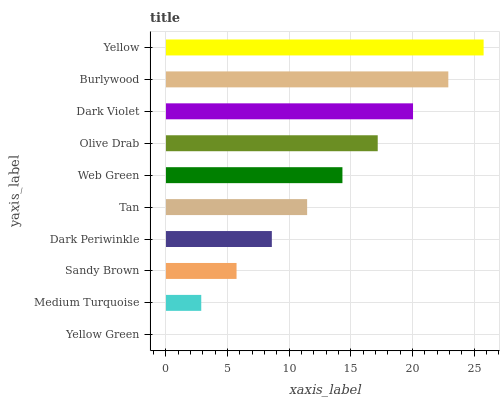Is Yellow Green the minimum?
Answer yes or no. Yes. Is Yellow the maximum?
Answer yes or no. Yes. Is Medium Turquoise the minimum?
Answer yes or no. No. Is Medium Turquoise the maximum?
Answer yes or no. No. Is Medium Turquoise greater than Yellow Green?
Answer yes or no. Yes. Is Yellow Green less than Medium Turquoise?
Answer yes or no. Yes. Is Yellow Green greater than Medium Turquoise?
Answer yes or no. No. Is Medium Turquoise less than Yellow Green?
Answer yes or no. No. Is Web Green the high median?
Answer yes or no. Yes. Is Tan the low median?
Answer yes or no. Yes. Is Sandy Brown the high median?
Answer yes or no. No. Is Dark Periwinkle the low median?
Answer yes or no. No. 